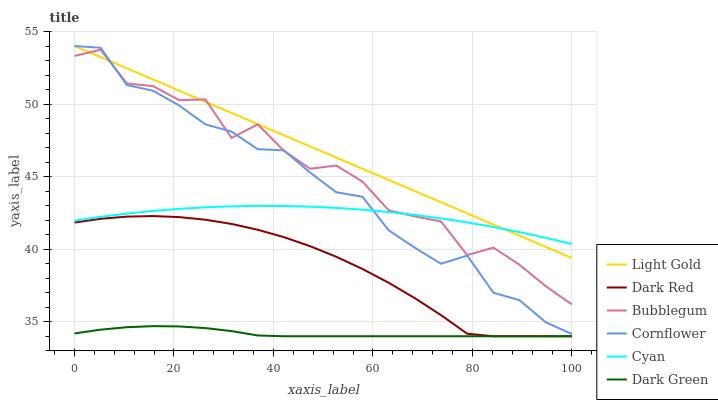Does Dark Green have the minimum area under the curve?
Answer yes or no. Yes. Does Light Gold have the maximum area under the curve?
Answer yes or no. Yes. Does Dark Red have the minimum area under the curve?
Answer yes or no. No. Does Dark Red have the maximum area under the curve?
Answer yes or no. No. Is Light Gold the smoothest?
Answer yes or no. Yes. Is Bubblegum the roughest?
Answer yes or no. Yes. Is Dark Red the smoothest?
Answer yes or no. No. Is Dark Red the roughest?
Answer yes or no. No. Does Dark Red have the lowest value?
Answer yes or no. Yes. Does Bubblegum have the lowest value?
Answer yes or no. No. Does Light Gold have the highest value?
Answer yes or no. Yes. Does Dark Red have the highest value?
Answer yes or no. No. Is Dark Red less than Light Gold?
Answer yes or no. Yes. Is Light Gold greater than Dark Green?
Answer yes or no. Yes. Does Dark Red intersect Dark Green?
Answer yes or no. Yes. Is Dark Red less than Dark Green?
Answer yes or no. No. Is Dark Red greater than Dark Green?
Answer yes or no. No. Does Dark Red intersect Light Gold?
Answer yes or no. No. 